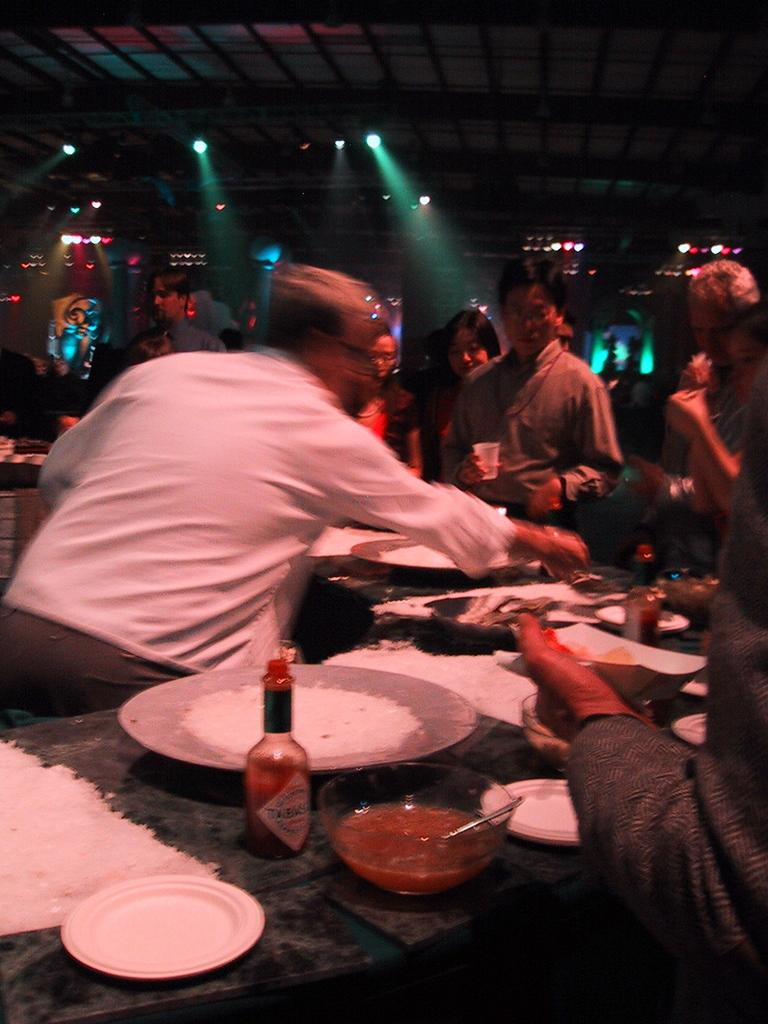What is the man in the image doing? The man is serving food in the image. What celestial bodies can be seen in the image? There are planets in the image. What type of condiments are on the table? There are sauces on the table. Who is present in front of the man serving food? There are people standing in front of the man. What are the people holding in their hands? The people are holding bowls and glasses in their hands. Can you describe the snake slithering across the table in the image? There is no snake present in the image; it only features a man serving food, planets, sauces, and people holding bowls and glasses. 